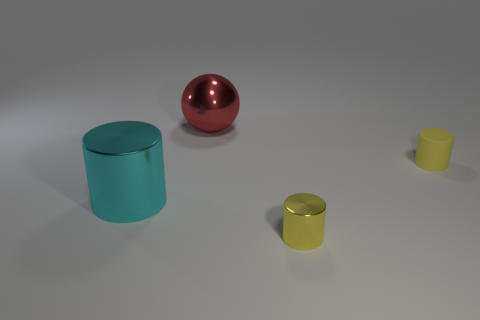Add 2 large purple cylinders. How many objects exist? 6 Subtract all cylinders. How many objects are left? 1 Add 4 large gray shiny balls. How many large gray shiny balls exist? 4 Subtract 0 cyan cubes. How many objects are left? 4 Subtract all purple matte balls. Subtract all metal cylinders. How many objects are left? 2 Add 3 metallic things. How many metallic things are left? 6 